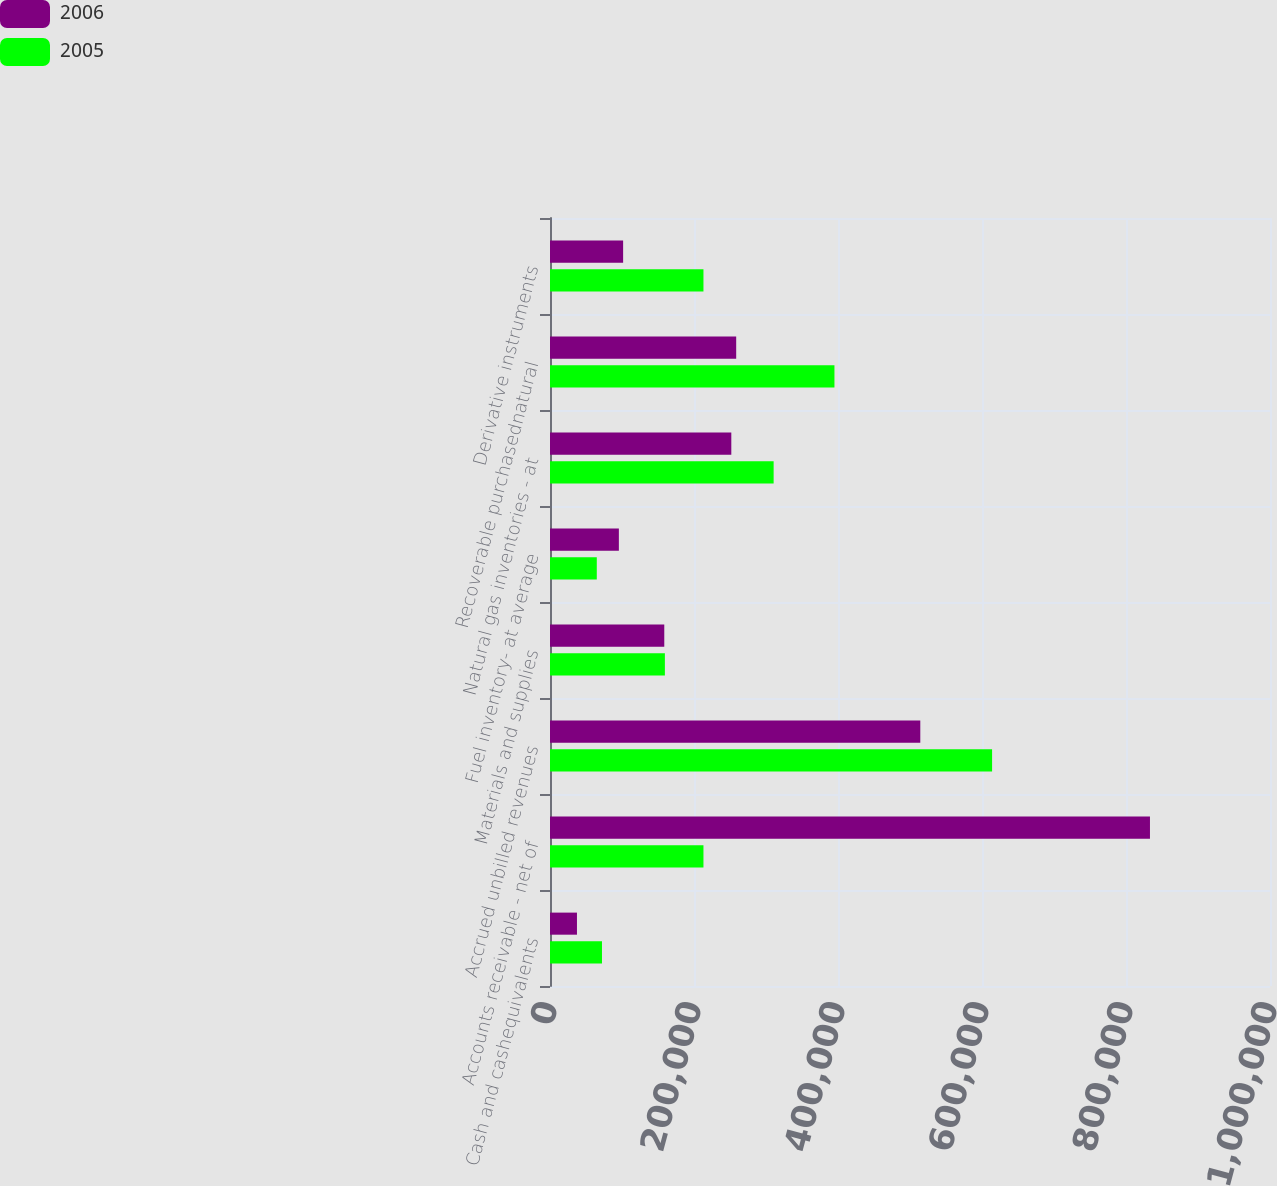<chart> <loc_0><loc_0><loc_500><loc_500><stacked_bar_chart><ecel><fcel>Cash and cashequivalents<fcel>Accounts receivable - net of<fcel>Accrued unbilled revenues<fcel>Materials and supplies<fcel>Fuel inventory- at average<fcel>Natural gas inventories - at<fcel>Recoverable purchasednatural<fcel>Derivative instruments<nl><fcel>2006<fcel>37458<fcel>833293<fcel>514300<fcel>158721<fcel>95651<fcel>251818<fcel>258600<fcel>101562<nl><fcel>2005<fcel>72196<fcel>213138<fcel>614016<fcel>159560<fcel>64987<fcel>310610<fcel>395070<fcel>213138<nl></chart> 